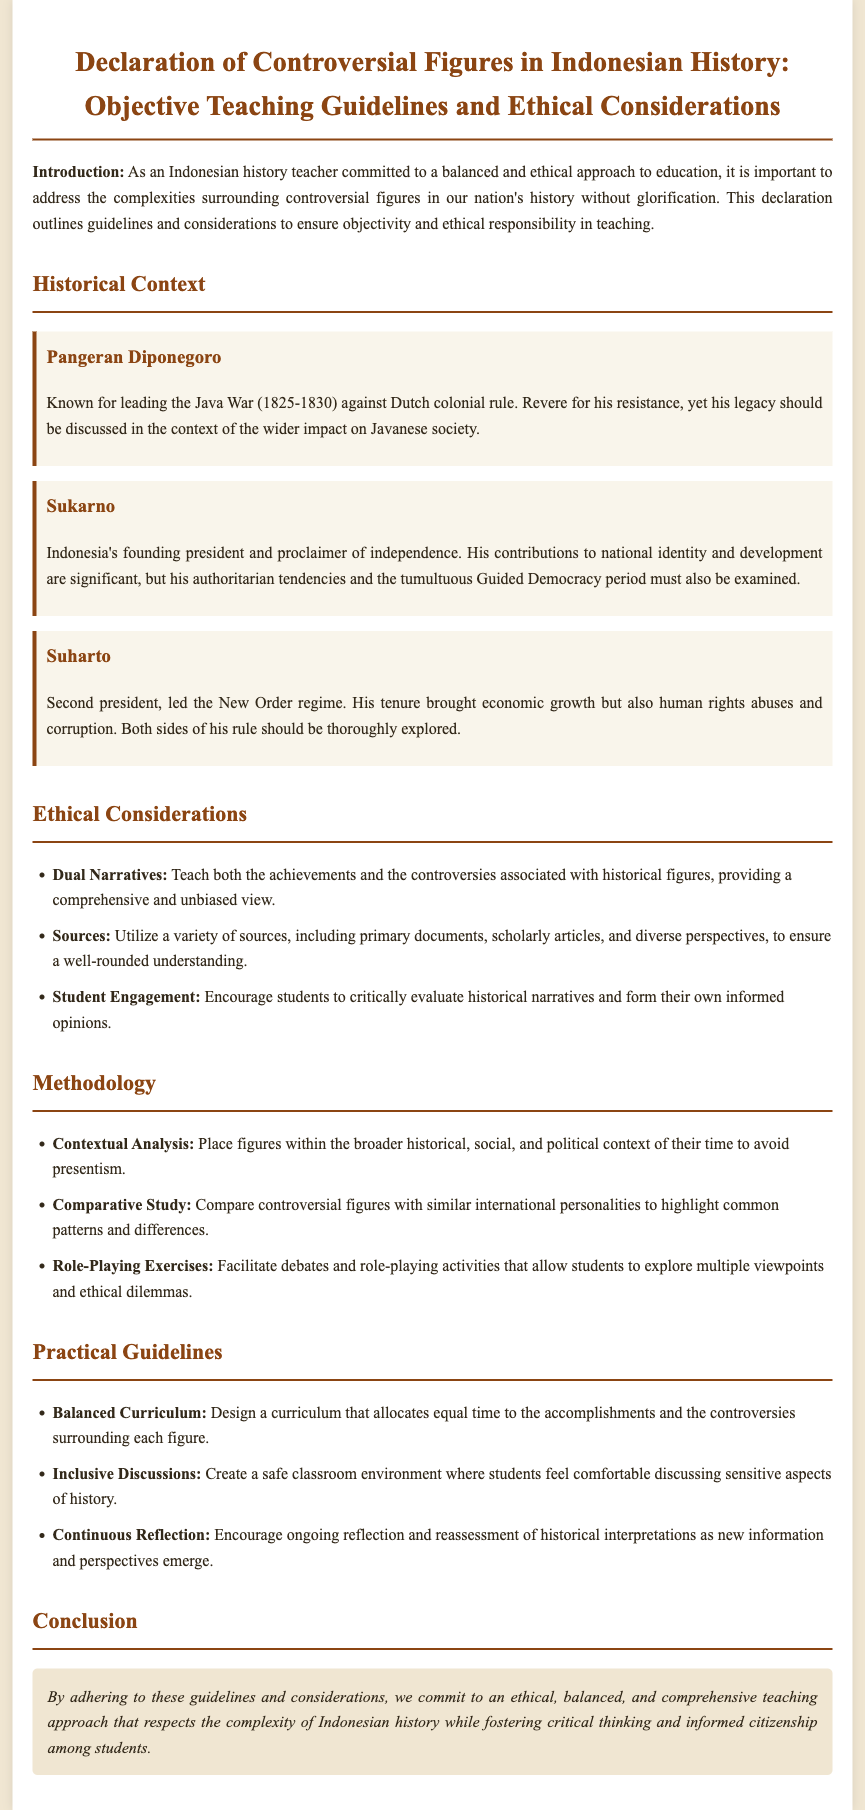What is the main focus of this declaration? The declaration primarily focuses on providing objective teaching guidelines and ethical considerations regarding controversial figures in Indonesian history.
Answer: Objective teaching guidelines and ethical considerations Who led the Java War? The document states that Pangeran Diponegoro is known for leading the Java War against Dutch colonial rule.
Answer: Pangeran Diponegoro How many historical figures are discussed in the document? There are three historical figures mentioned in the document, which are Pangeran Diponegoro, Sukarno, and Suharto.
Answer: Three What aspect of Sukarno's leadership does the document highlight? The document highlights Sukarno's contributions to national identity and development, as well as his authoritarian tendencies.
Answer: Authoritarian tendencies What type of analysis is recommended for contextualizing historical figures? The document recommends contextual analysis to place figures within the broader historical, social, and political context of their time.
Answer: Contextual Analysis What is one of the ethical considerations mentioned in the document? The document mentions that teachers should provide dual narratives to teach both achievements and controversies associated with historical figures.
Answer: Dual Narratives Which activity is suggested to help students explore multiple viewpoints? Role-playing exercises are suggested as a way to allow students to explore multiple viewpoints and ethical dilemmas.
Answer: Role-Playing Exercises What is the last section of the document titled? The last section of the document is titled "Conclusion."
Answer: Conclusion 